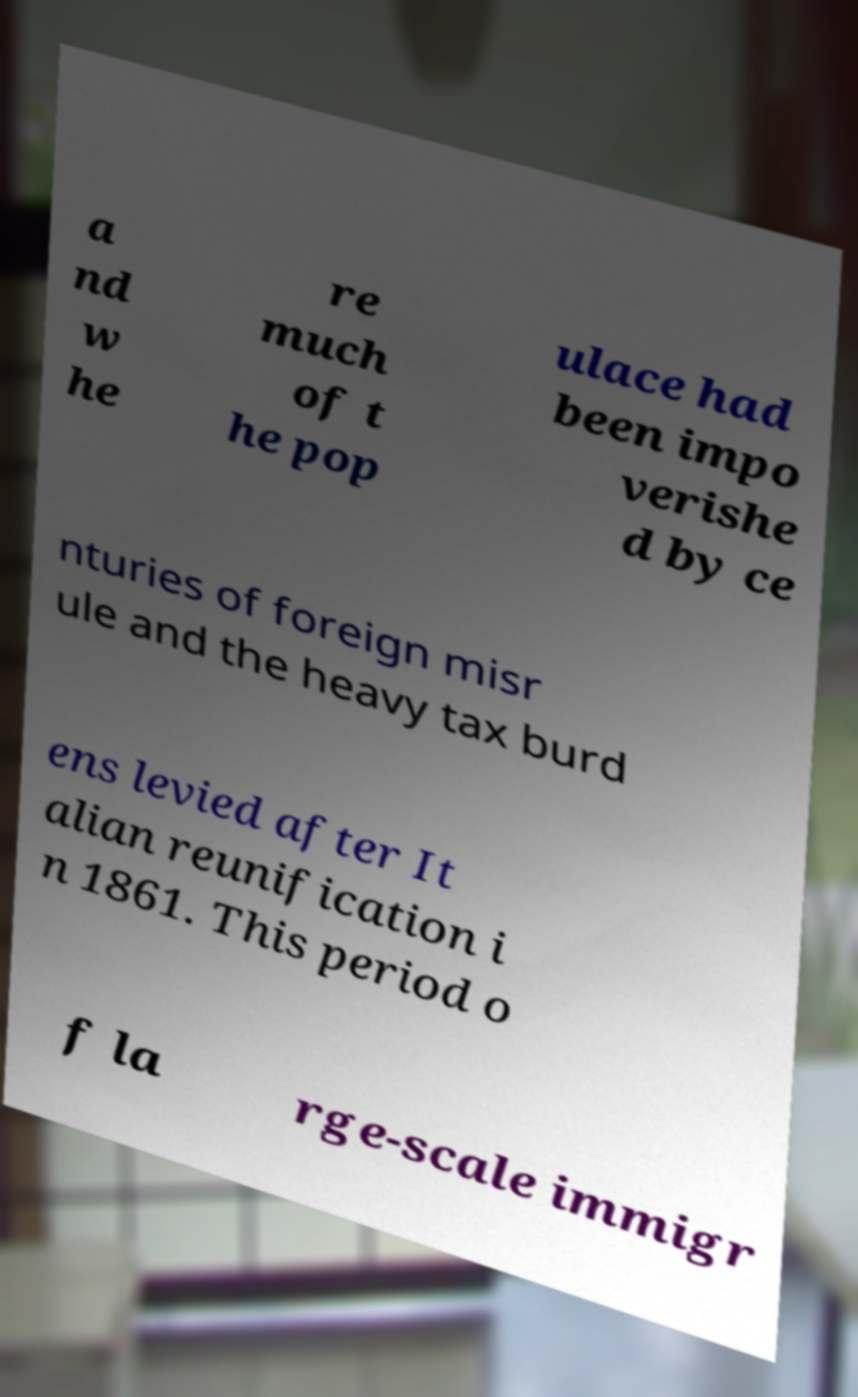Can you read and provide the text displayed in the image?This photo seems to have some interesting text. Can you extract and type it out for me? a nd w he re much of t he pop ulace had been impo verishe d by ce nturies of foreign misr ule and the heavy tax burd ens levied after It alian reunification i n 1861. This period o f la rge-scale immigr 